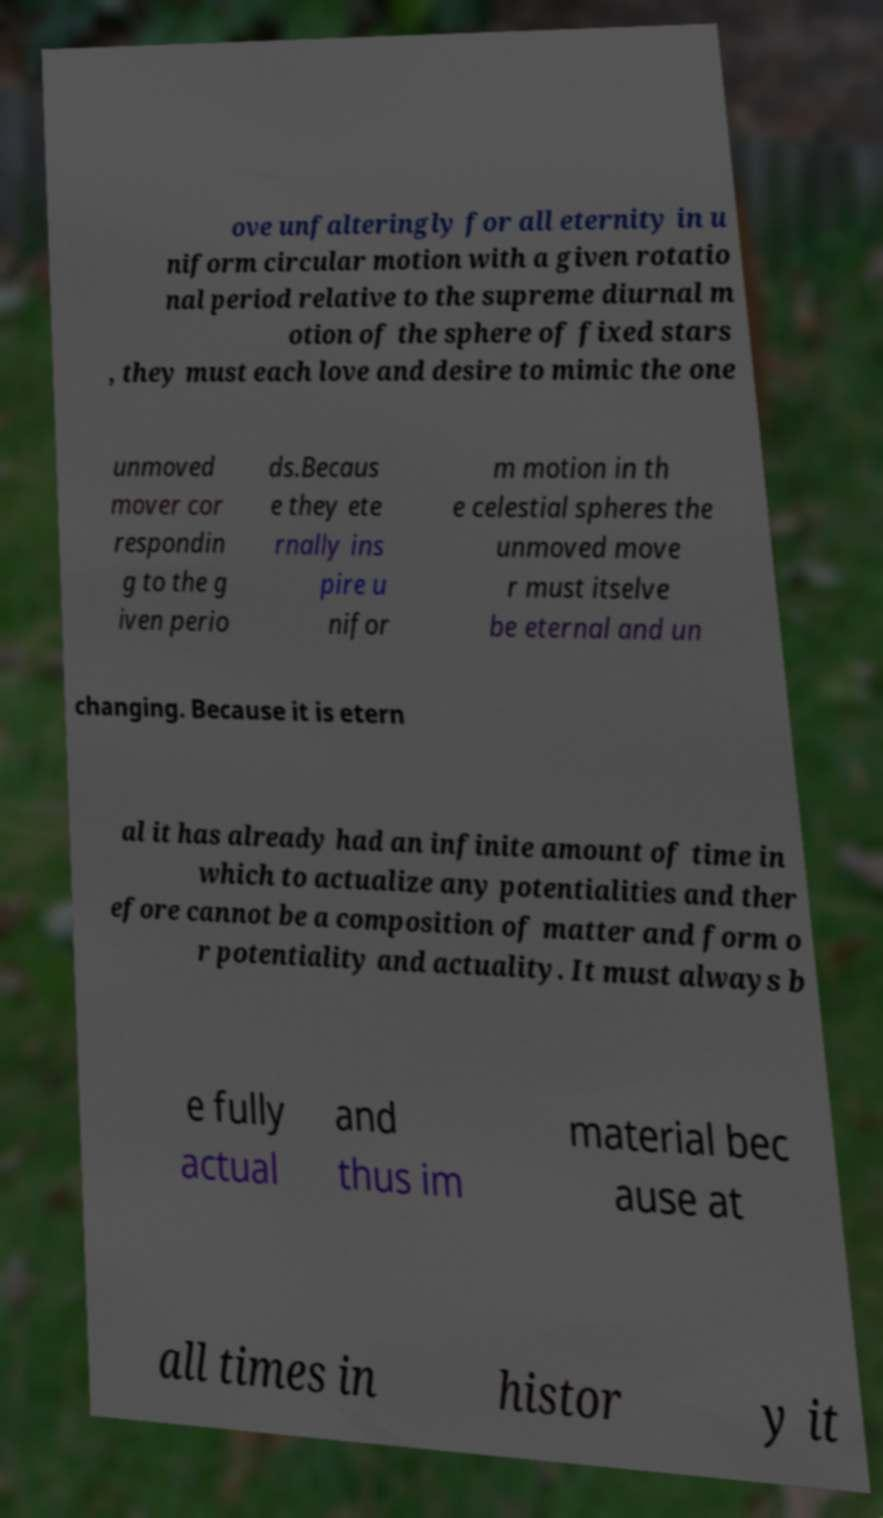There's text embedded in this image that I need extracted. Can you transcribe it verbatim? ove unfalteringly for all eternity in u niform circular motion with a given rotatio nal period relative to the supreme diurnal m otion of the sphere of fixed stars , they must each love and desire to mimic the one unmoved mover cor respondin g to the g iven perio ds.Becaus e they ete rnally ins pire u nifor m motion in th e celestial spheres the unmoved move r must itselve be eternal and un changing. Because it is etern al it has already had an infinite amount of time in which to actualize any potentialities and ther efore cannot be a composition of matter and form o r potentiality and actuality. It must always b e fully actual and thus im material bec ause at all times in histor y it 